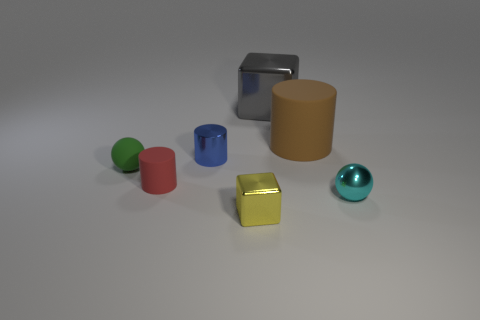Subtract all tiny cylinders. How many cylinders are left? 1 Add 1 big metallic things. How many objects exist? 8 Subtract all gray cubes. How many cubes are left? 1 Subtract all spheres. How many objects are left? 5 Subtract 1 green balls. How many objects are left? 6 Subtract 1 cubes. How many cubes are left? 1 Subtract all cyan balls. Subtract all blue cylinders. How many balls are left? 1 Subtract all gray blocks. How many brown cylinders are left? 1 Subtract all tiny gray metallic blocks. Subtract all blue cylinders. How many objects are left? 6 Add 5 large objects. How many large objects are left? 7 